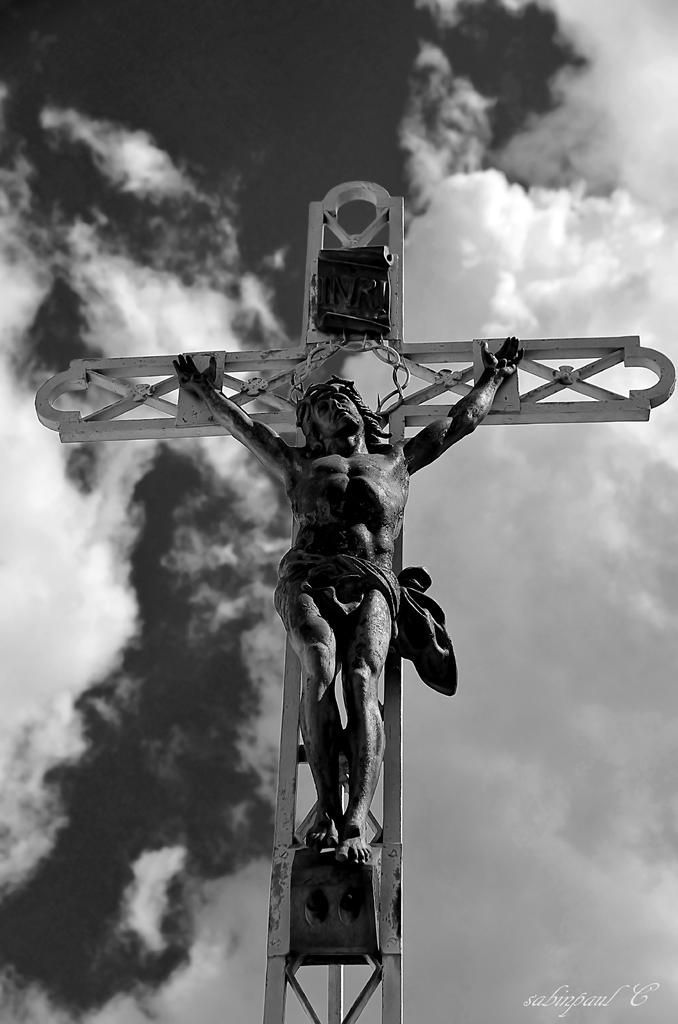What type of image is in the picture? The image contains a black and white picture. What is the subject of the black and white picture? The picture depicts a statue of a person. How is the statue supported in the image? The statue is on a metal rod. What can be seen in the background of the picture? There is a sky visible in the background of the picture. What type of juice is being served at the bridge in the image? There is no juice or bridge present in the image; it features a black and white picture of a statue on a metal rod with a sky in the background. 